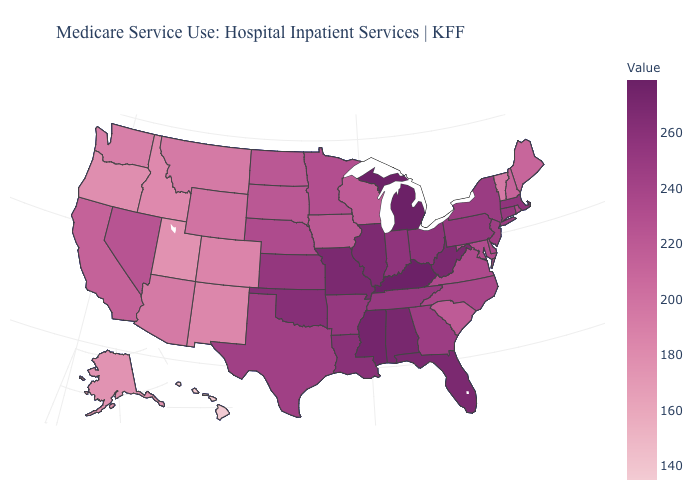Among the states that border Utah , does Nevada have the highest value?
Concise answer only. Yes. Does the map have missing data?
Give a very brief answer. No. Which states have the highest value in the USA?
Quick response, please. Kentucky, Michigan. Among the states that border Arizona , does Nevada have the lowest value?
Keep it brief. No. Does the map have missing data?
Concise answer only. No. 